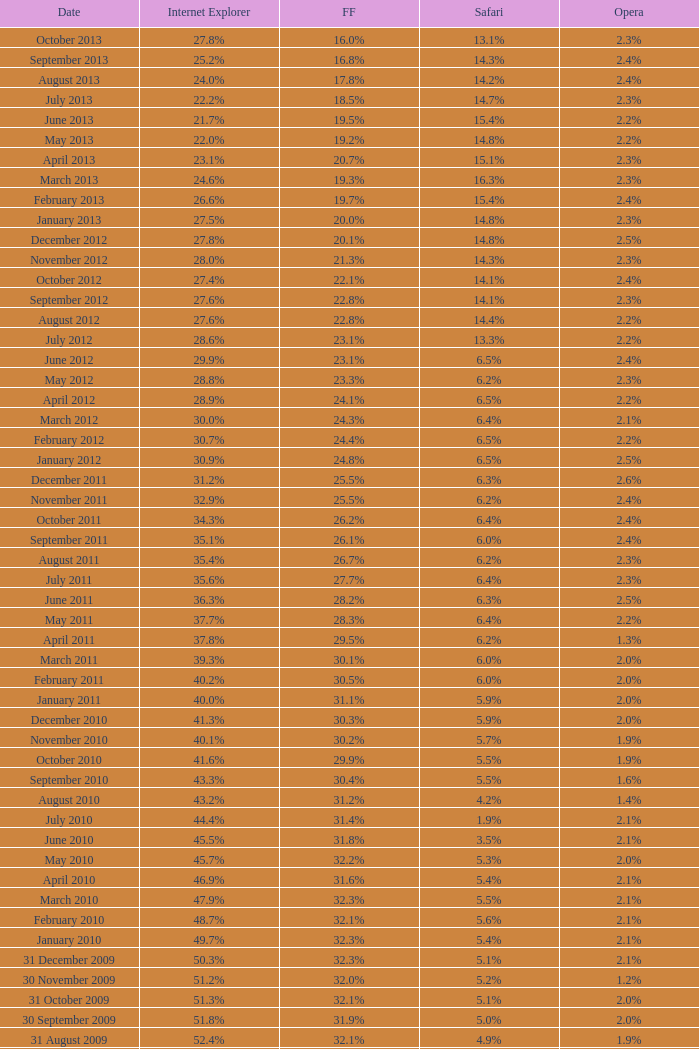0% internet explorer? 14.3%. 